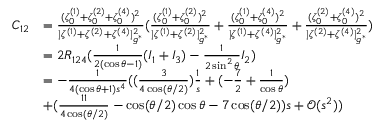<formula> <loc_0><loc_0><loc_500><loc_500>\begin{array} { r l } { C _ { 1 2 } } & { = \frac { ( \zeta _ { 0 } ^ { ( 1 ) } + \zeta _ { 0 } ^ { ( 2 ) } + \zeta _ { 0 } ^ { ( 4 ) } ) ^ { 2 } } { | \zeta ^ { ( 1 ) } + \zeta ^ { ( 2 ) } + \zeta ^ { ( 4 ) } | _ { g ^ { * } } ^ { 2 } } ( \frac { ( \zeta _ { 0 } ^ { ( 1 ) } + \zeta _ { 0 } ^ { ( 2 ) } ) ^ { 2 } } { | \zeta ^ { ( 1 ) } + \zeta ^ { ( 2 ) } | _ { g ^ { * } } ^ { 2 } } + \frac { ( \zeta _ { 0 } ^ { ( 1 ) } + \zeta _ { 0 } ^ { ( 4 ) } ) ^ { 2 } } { | \zeta ^ { ( 1 ) } + \zeta ^ { ( 4 ) } | _ { g ^ { * } } ^ { 2 } } + \frac { ( \zeta _ { 0 } ^ { ( 2 ) } + \zeta _ { 0 } ^ { ( 4 ) } ) ^ { 2 } } { | \zeta ^ { ( 2 ) } + \zeta ^ { ( 4 ) } | _ { g ^ { * } } ^ { 2 } } ) } \\ & { = 2 R _ { 1 2 4 } ( \frac { 1 } { 2 ( \cos \theta - 1 ) } ( I _ { 1 } + I _ { 3 } ) - \frac { 1 } { 2 \sin ^ { 2 } \theta } I _ { 2 } ) } \\ & { = - \frac { 1 } { 4 ( \cos \theta + 1 ) s ^ { 4 } } ( ( \frac { 3 } { 4 \cos ( { \theta } / { 2 } ) } ) \frac { 1 } { s } + ( - \frac { 7 } { 2 } + \frac { 1 } { \cos \theta } ) } \\ & { + ( \frac { 1 1 } { 4 \cos ( { \theta } / { 2 } ) } - \cos ( { \theta } / { 2 } ) \cos \theta - 7 \cos ( { \theta } / { 2 } ) ) s + \mathcal { O } ( s ^ { 2 } ) ) } \end{array}</formula> 